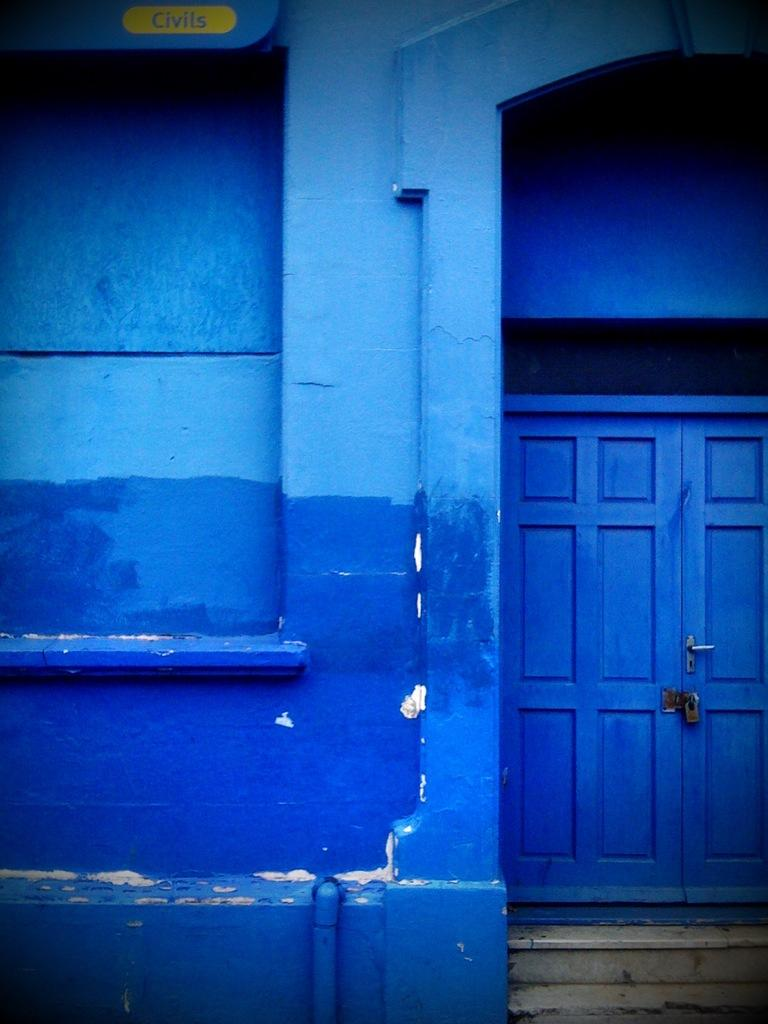What type of door is visible in the image? There is a locked wooden door in the image. What is located beside the door in the image? There is a wall beside the door in the image. What type of apparatus is hanging on the wall beside the door in the image? There is no apparatus visible on the wall beside the door in the image. Can you describe the picture hanging on the wall beside the door in the image? There is no picture hanging on the wall beside the door in the image. 